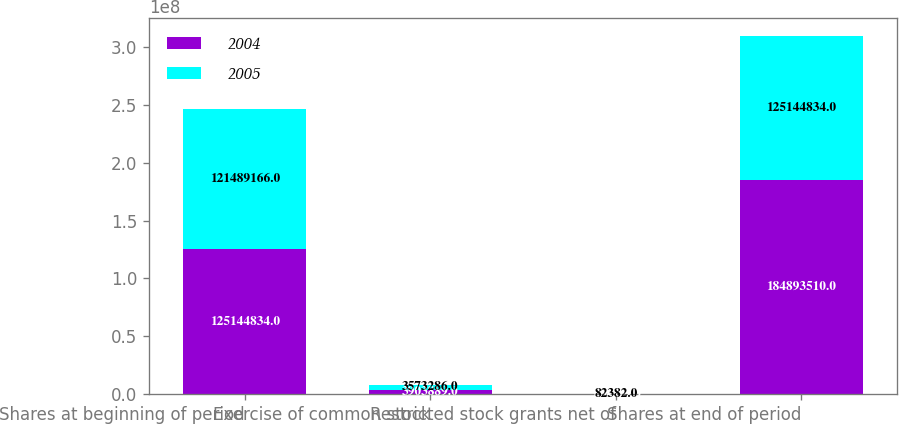Convert chart to OTSL. <chart><loc_0><loc_0><loc_500><loc_500><stacked_bar_chart><ecel><fcel>Shares at beginning of period<fcel>Exercise of common stock<fcel>Restricted stock grants net of<fcel>Shares at end of period<nl><fcel>2004<fcel>1.25145e+08<fcel>3.90389e+06<fcel>174379<fcel>1.84894e+08<nl><fcel>2005<fcel>1.21489e+08<fcel>3.57329e+06<fcel>82382<fcel>1.25145e+08<nl></chart> 